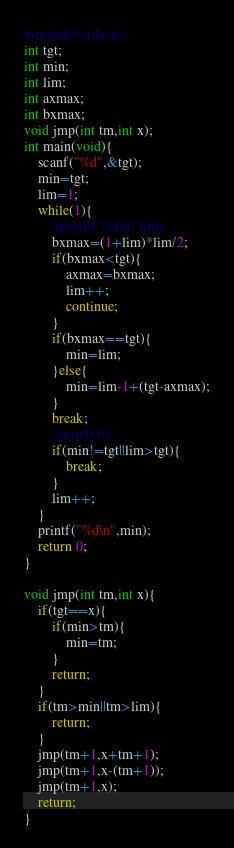Convert code to text. <code><loc_0><loc_0><loc_500><loc_500><_C_>#include<stdio.h>
int tgt;
int min;
int lim;
int axmax;
int bxmax;
void jmp(int tm,int x);
int main(void){
    scanf("%d",&tgt);
    min=tgt;
    lim=1;
    while(1){
        //printf("%d\n",lim);
        bxmax=(1+lim)*lim/2;
        if(bxmax<tgt){
            axmax=bxmax;
            lim++;
            continue;
        }
        if(bxmax==tgt){
            min=lim;
        }else{
            min=lim-1+(tgt-axmax);
        }
        break;
        //jmp(0,0);
        if(min!=tgt||lim>tgt){
            break;
        }
        lim++;
    }
    printf("%d\n",min);
    return 0;
}

void jmp(int tm,int x){
    if(tgt==x){
        if(min>tm){
            min=tm;
        }
        return;
    }
    if(tm>min||tm>lim){
        return;
    }
    jmp(tm+1,x+tm+1);
    jmp(tm+1,x-(tm+1));
    jmp(tm+1,x);
    return;
}
</code> 